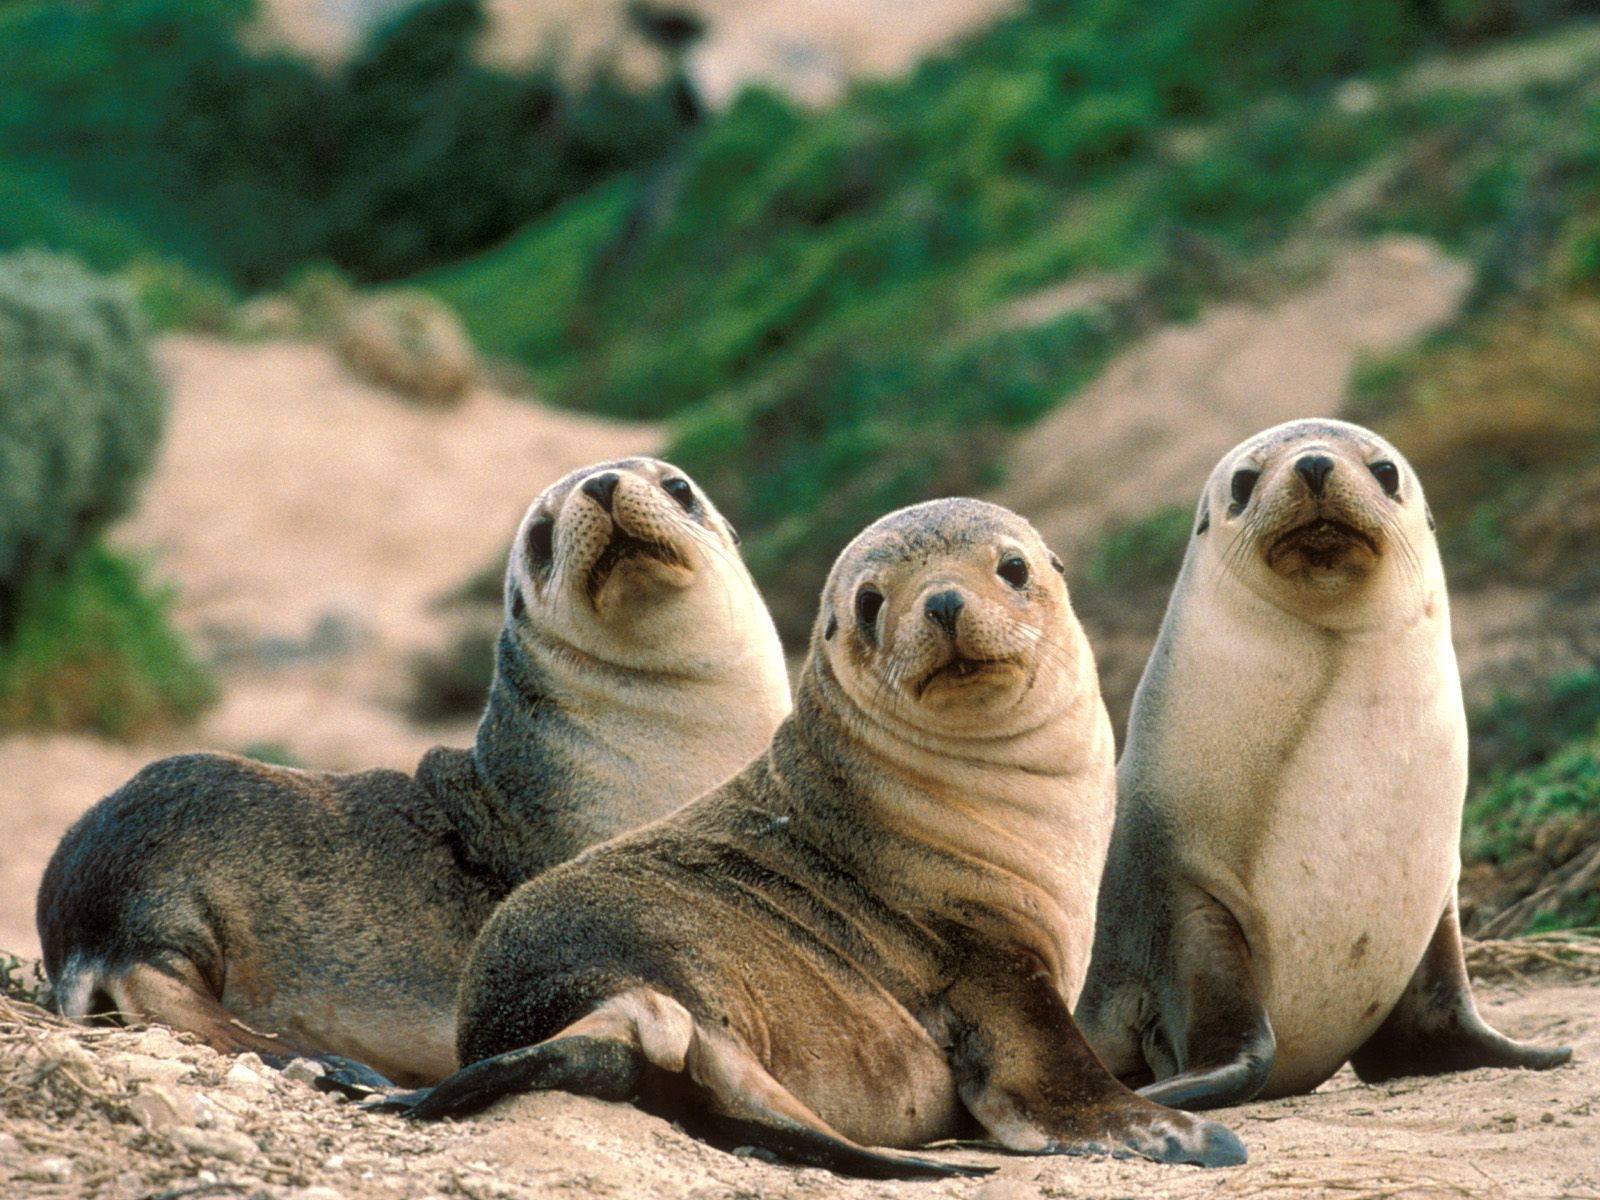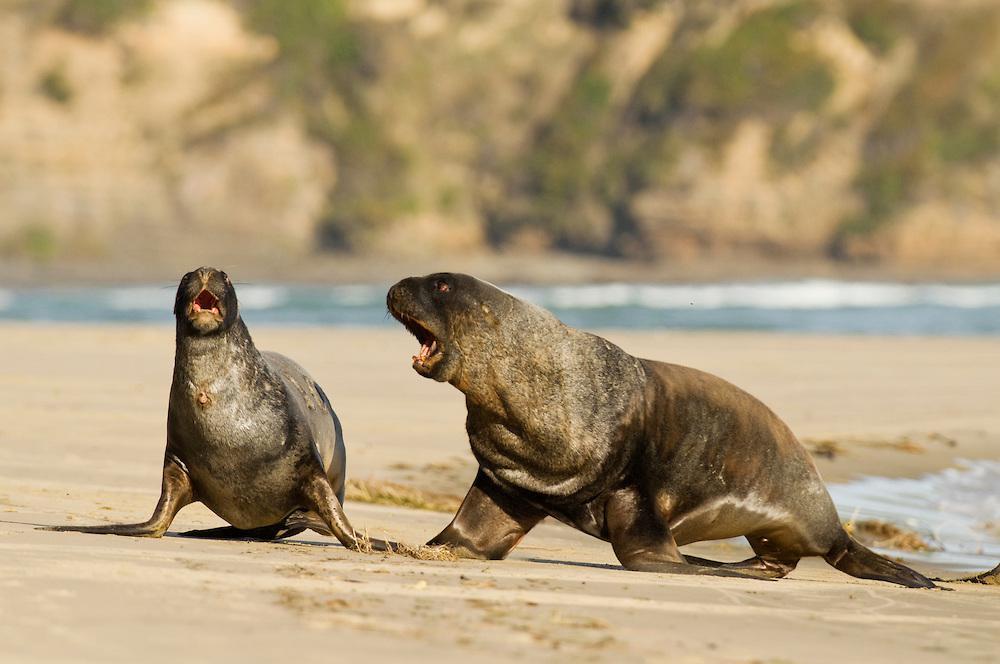The first image is the image on the left, the second image is the image on the right. Examine the images to the left and right. Is the description "An image shows exactly two seals, both with their mouths opened." accurate? Answer yes or no. Yes. The first image is the image on the left, the second image is the image on the right. Evaluate the accuracy of this statement regarding the images: "There are no more than five sea animals on the shore.". Is it true? Answer yes or no. Yes. 